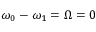Convert formula to latex. <formula><loc_0><loc_0><loc_500><loc_500>\omega _ { 0 } - \omega _ { 1 } = \Omega = 0</formula> 